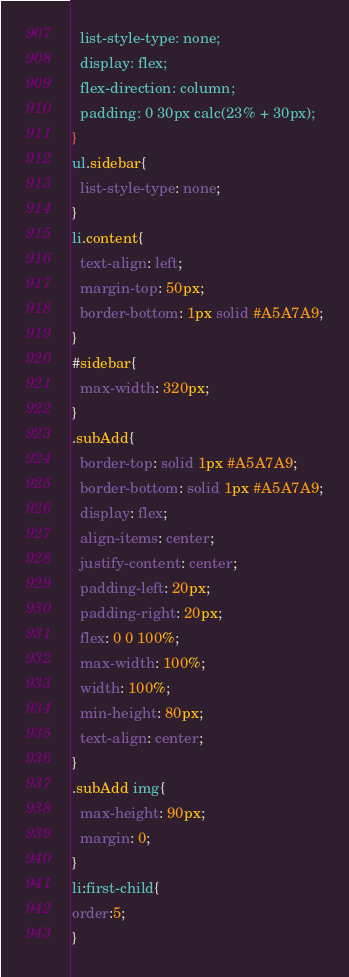Convert code to text. <code><loc_0><loc_0><loc_500><loc_500><_CSS_>  list-style-type: none;
  display: flex;
  flex-direction: column;
  padding: 0 30px calc(23% + 30px);
}
ul.sidebar{
  list-style-type: none;
}
li.content{
  text-align: left;
  margin-top: 50px;
  border-bottom: 1px solid #A5A7A9;
}
#sidebar{
  max-width: 320px;
}
.subAdd{
  border-top: solid 1px #A5A7A9;
  border-bottom: solid 1px #A5A7A9;
  display: flex;
  align-items: center;
  justify-content: center;
  padding-left: 20px;
  padding-right: 20px;
  flex: 0 0 100%;
  max-width: 100%;
  width: 100%;
  min-height: 80px;
  text-align: center;
}
.subAdd img{
  max-height: 90px;
  margin: 0;
}
li:first-child{
order:5;
}
</code> 